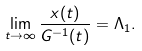Convert formula to latex. <formula><loc_0><loc_0><loc_500><loc_500>\lim _ { t \to \infty } \frac { x ( t ) } { G ^ { - 1 } ( t ) } = \Lambda _ { 1 } .</formula> 